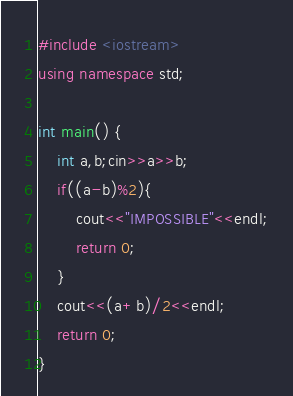Convert code to text. <code><loc_0><loc_0><loc_500><loc_500><_C++_>#include <iostream>
using namespace std;

int main() {
	int a,b;cin>>a>>b;
	if((a-b)%2){
		cout<<"IMPOSSIBLE"<<endl;
		return 0;
	}
	cout<<(a+b)/2<<endl;
	return 0;
}
</code> 